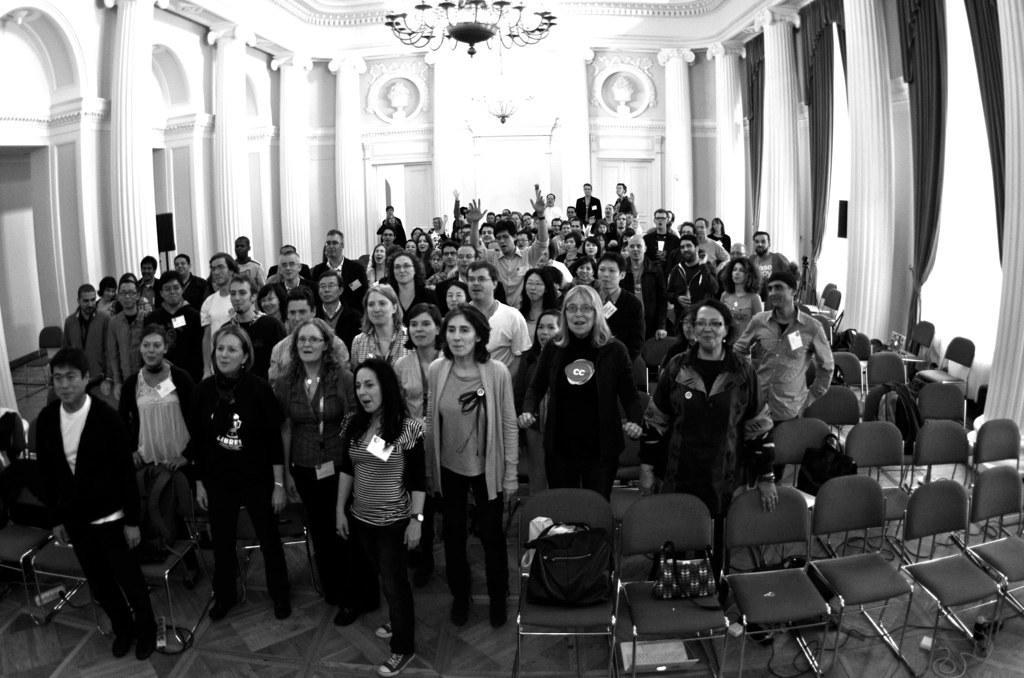Could you give a brief overview of what you see in this image? This image is a black and white image. This image is taken indoors. At the bottom of the image there is a floor. In the middle of the image many people are standing on the floor and there are many empty chairs with a few handbags on them. In the background there are a few walls with pillars and carvings. There are a few windows with curtains. There are a few inches. At the top of the image there is a ceiling with a chandelier. 